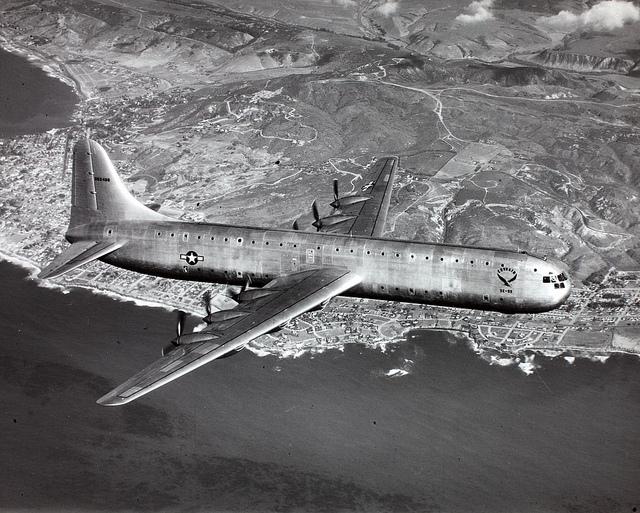Is the plane on the ground?
Short answer required. No. Is this flight operated by Delta?
Quick response, please. No. How high up is the airplane?
Answer briefly. 25000 ft. Where was this photo taken?
Quick response, please. Sky. 